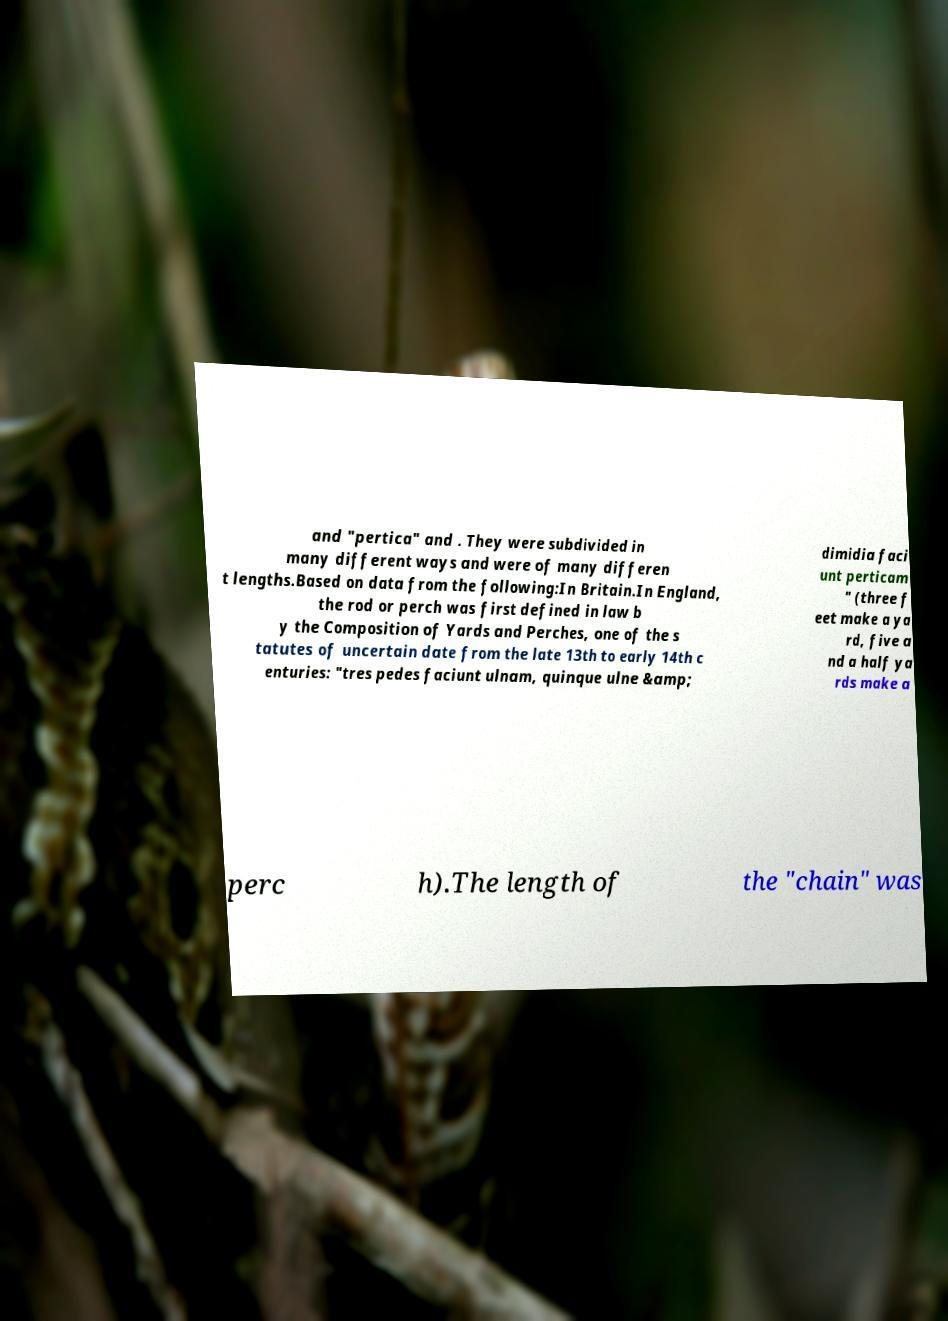Can you read and provide the text displayed in the image?This photo seems to have some interesting text. Can you extract and type it out for me? and "pertica" and . They were subdivided in many different ways and were of many differen t lengths.Based on data from the following:In Britain.In England, the rod or perch was first defined in law b y the Composition of Yards and Perches, one of the s tatutes of uncertain date from the late 13th to early 14th c enturies: "tres pedes faciunt ulnam, quinque ulne &amp; dimidia faci unt perticam " (three f eet make a ya rd, five a nd a half ya rds make a perc h).The length of the "chain" was 